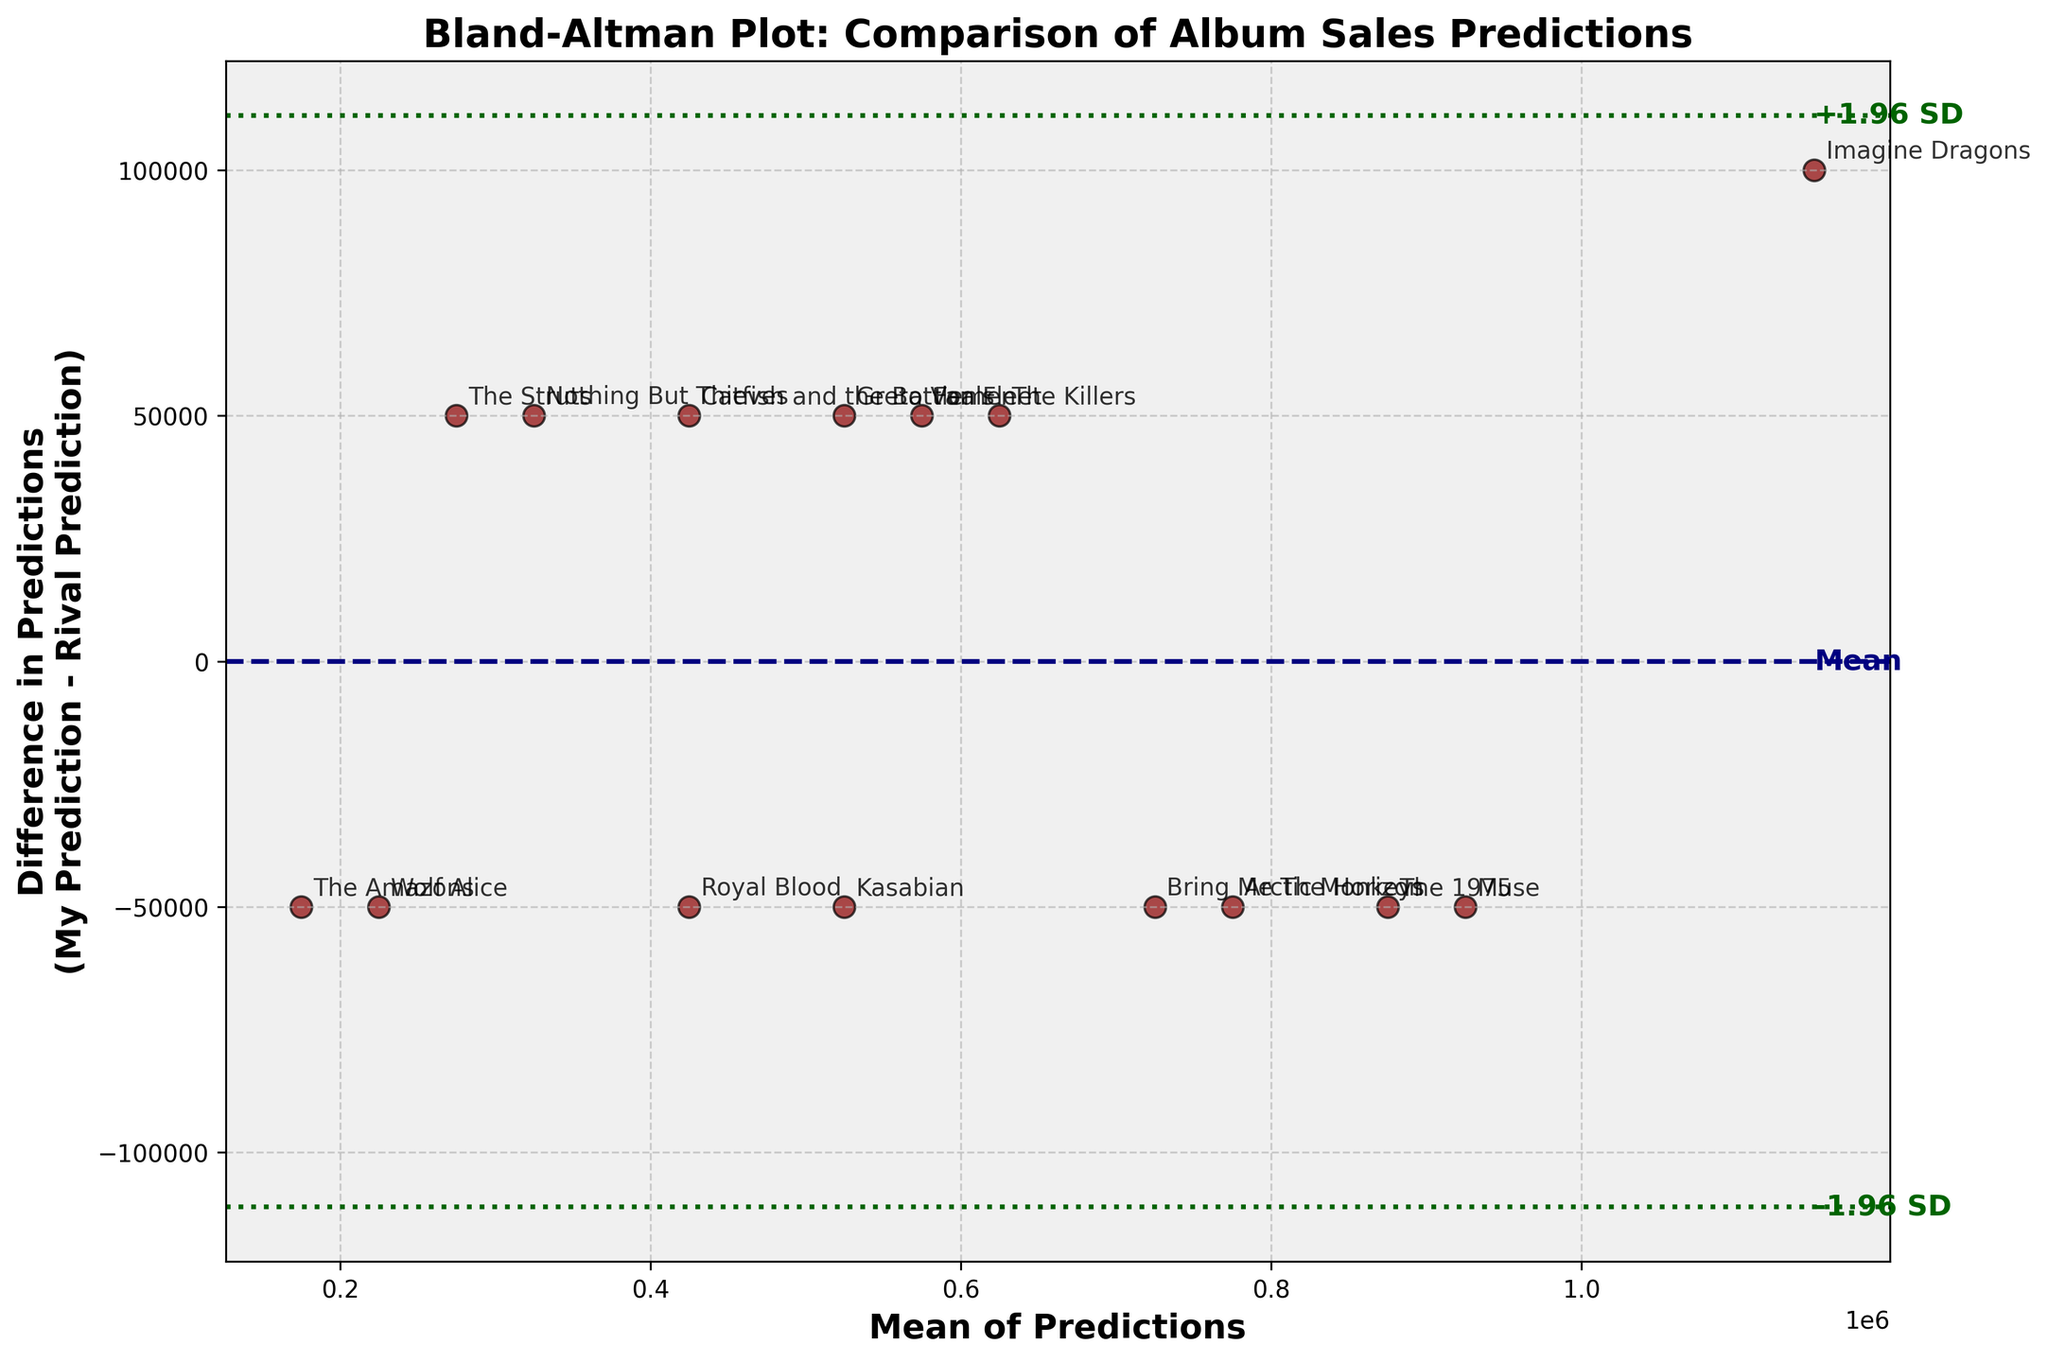How many bands are represented in the plot? Count the data points in the plot, as each point represents a band. We can see 15 data points in total.
Answer: 15 What is the title of the plot? The title is located at the top of the plot. It reads 'Bland-Altman Plot: Comparison of Album Sales Predictions'.
Answer: Bland-Altman Plot: Comparison of Album Sales Predictions What do the dashed lines in the plot represent? The dashed lines are parallel to the average difference line. They represent the limits of agreement (+1.96 SD and -1.96 SD).
Answer: Limits of agreement What is the mean difference line positioned at? The mean difference line is indicated as ‘Mean’ and positioned horizontally at the value where the average of the differences between predictions lies.
Answer: Mean difference Which band has the largest positive difference, and what is that difference? Look for the data point that is the highest above the mean difference line. The band labeled 'The Struts' shows the largest positive difference which is 50,000.
Answer: The Struts, 50,000 Which band has the largest negative difference, and what is that difference? Look for the data point that is the lowest below the mean difference line. The band labeled 'Imagine Dragons' shows the largest negative difference which is -100,000.
Answer: Imagine Dragons, -100,000 For what range of mean predictions do most data points fall? Examine the x-axis, which shows the mean predictions of both scouts. Most data points are concentrated between 300,000 and 800,000.
Answer: 300,000 to 800,000 What color and style are used to indicate +1.96 SD and -1.96 SD lines? The +1.96 SD and -1.96 SD lines are indicated by green dotted lines. These lines mark the limits of agreement.
Answer: Green dotted lines Are there any bands within the limits of agreement but far from the mean difference? Identify data points far from the mean difference line but still within the green dotted lines. 'Royal Blood' and 'Greta Van Fleet' are close to the limits but within the agreement range.
Answer: Royal Blood, Greta Van Fleet 